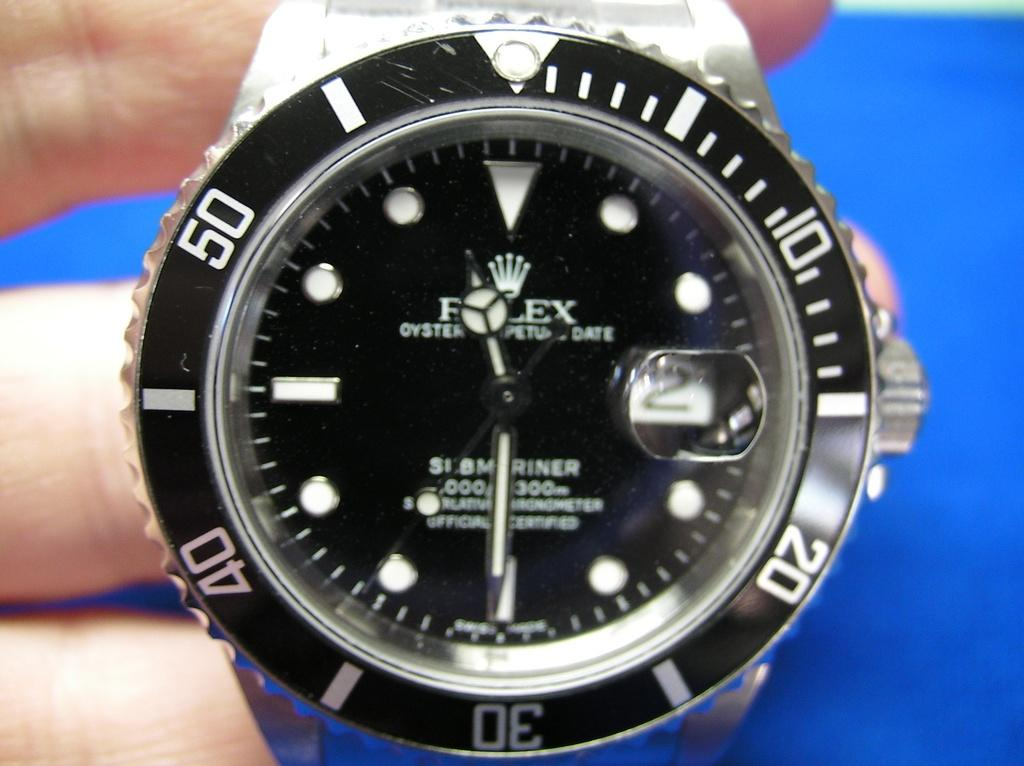<image>
Share a concise interpretation of the image provided. A watch has the word oyster on the face of it. 